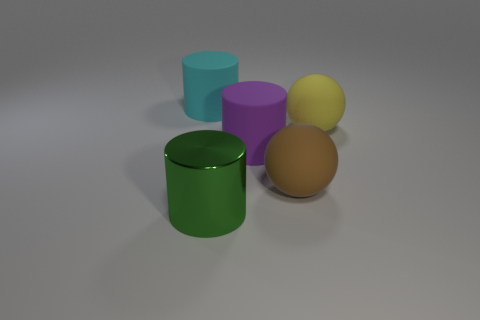How many large brown things are in front of the purple matte thing?
Your response must be concise. 1. The big green object that is left of the rubber sphere that is to the left of the large yellow matte sphere is made of what material?
Keep it short and to the point. Metal. How many things are large cylinders on the left side of the green shiny thing or matte things to the right of the large brown matte sphere?
Offer a terse response. 2. Is the number of objects that are on the left side of the large yellow object greater than the number of green objects?
Make the answer very short. Yes. How many other objects are there of the same shape as the big green object?
Give a very brief answer. 2. What material is the large thing that is in front of the large yellow thing and on the left side of the purple rubber thing?
Keep it short and to the point. Metal. How many objects are either metallic things or large cylinders?
Give a very brief answer. 3. Are there more purple matte objects than large red matte blocks?
Offer a terse response. Yes. What is the size of the matte sphere on the right side of the matte object in front of the large purple rubber object?
Offer a terse response. Large. There is another large metallic thing that is the same shape as the large purple object; what is its color?
Your answer should be compact. Green. 